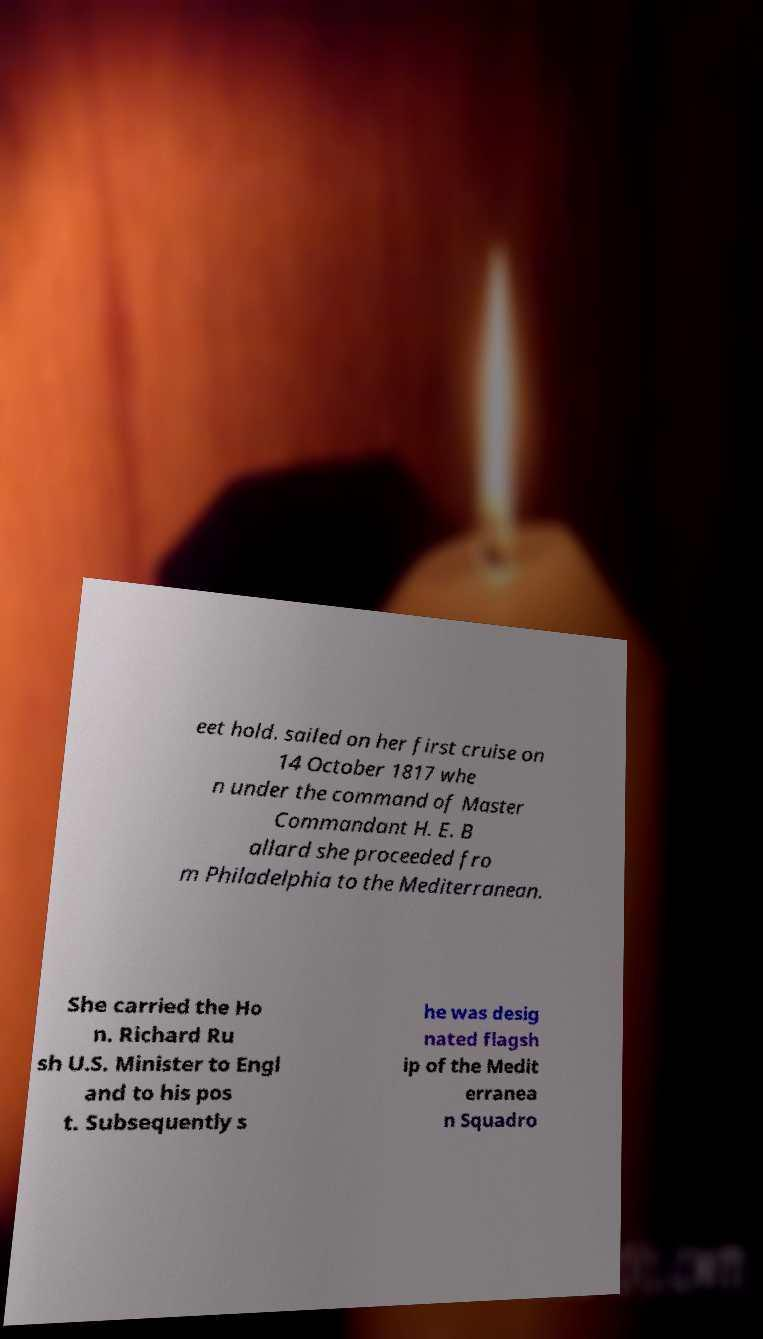There's text embedded in this image that I need extracted. Can you transcribe it verbatim? eet hold. sailed on her first cruise on 14 October 1817 whe n under the command of Master Commandant H. E. B allard she proceeded fro m Philadelphia to the Mediterranean. She carried the Ho n. Richard Ru sh U.S. Minister to Engl and to his pos t. Subsequently s he was desig nated flagsh ip of the Medit erranea n Squadro 